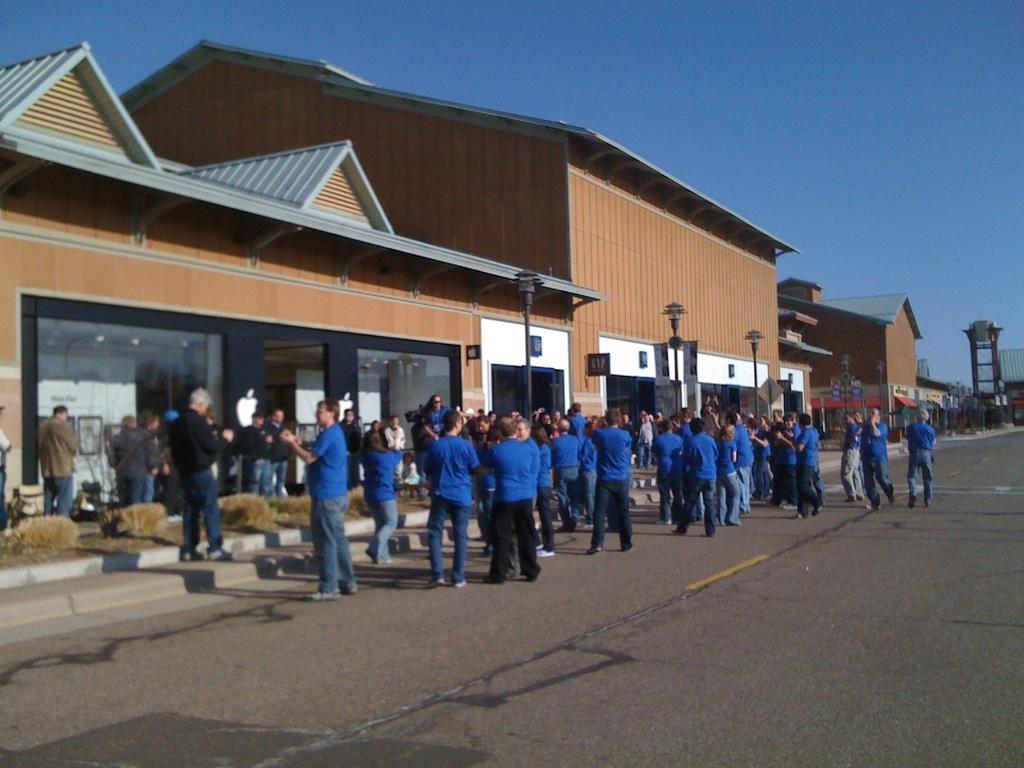In one or two sentences, can you explain what this image depicts? In this image I can see number of people are standing. I can see most of them are wearing blue colour dress. In the background I can see few buildings, streetlights and the sky. 